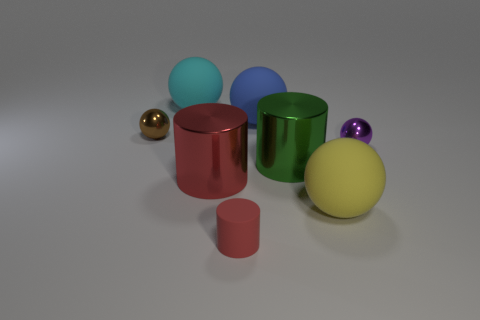Are there the same number of small purple spheres that are in front of the large yellow sphere and big yellow spheres in front of the purple metal ball?
Offer a terse response. No. Do the large green metal thing and the small object behind the purple ball have the same shape?
Your response must be concise. No. How many other things are made of the same material as the tiny red thing?
Make the answer very short. 3. Are there any red cylinders in front of the large red metal object?
Offer a very short reply. Yes. Do the red rubber cylinder and the yellow matte thing left of the purple ball have the same size?
Your response must be concise. No. There is a small metal object on the right side of the ball in front of the large green metallic cylinder; what color is it?
Your answer should be very brief. Purple. Is the size of the brown sphere the same as the green shiny object?
Offer a terse response. No. There is a big matte thing that is right of the small red rubber cylinder and behind the large yellow ball; what color is it?
Offer a terse response. Blue. What size is the yellow matte sphere?
Your response must be concise. Large. Do the big cylinder that is left of the red rubber cylinder and the tiny cylinder have the same color?
Offer a very short reply. Yes. 